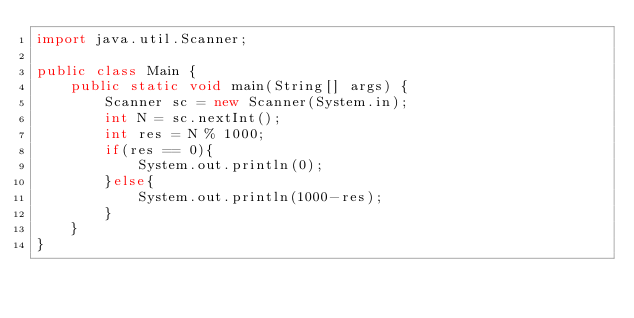Convert code to text. <code><loc_0><loc_0><loc_500><loc_500><_Java_>import java.util.Scanner;

public class Main {
    public static void main(String[] args) {
        Scanner sc = new Scanner(System.in);
        int N = sc.nextInt();
        int res = N % 1000;
        if(res == 0){
            System.out.println(0);
        }else{
            System.out.println(1000-res);
        }
    }
}</code> 